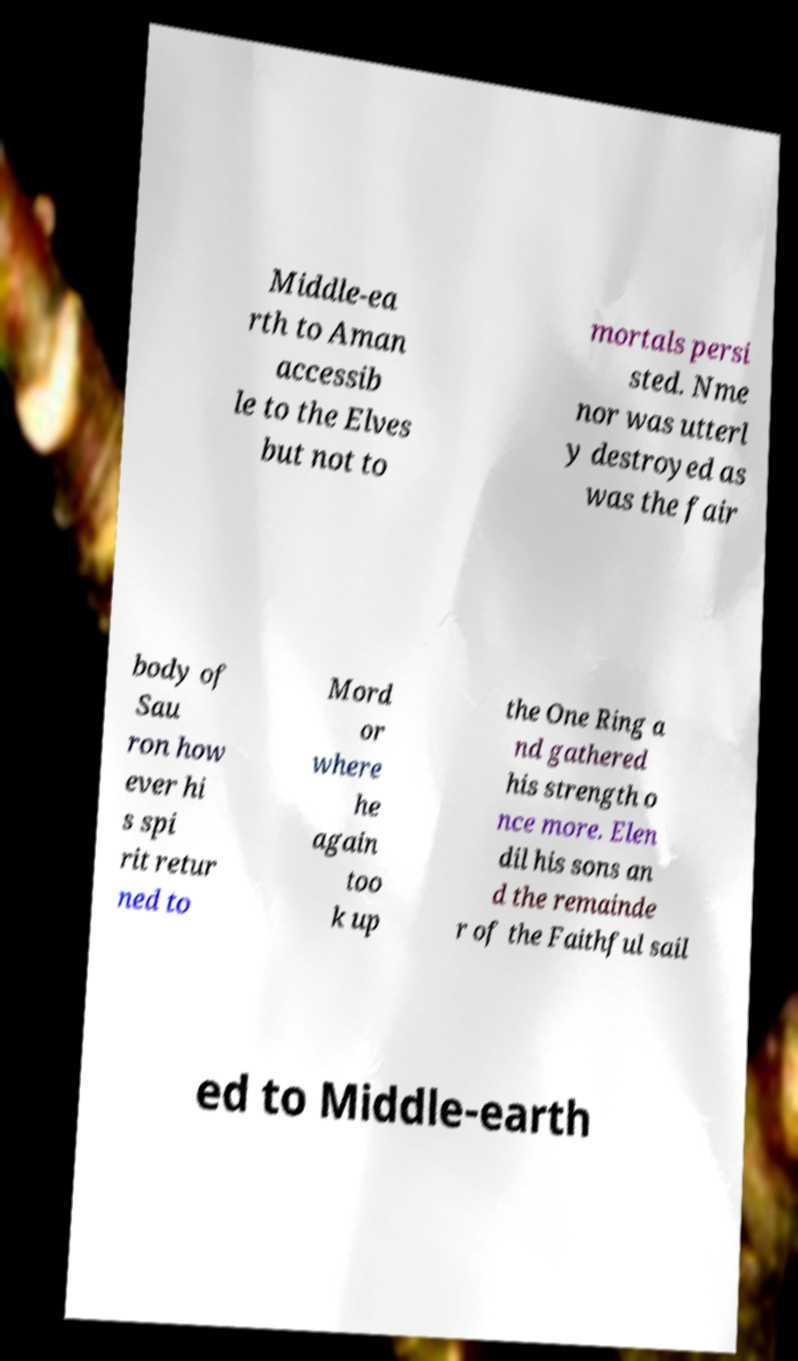Please read and relay the text visible in this image. What does it say? Middle-ea rth to Aman accessib le to the Elves but not to mortals persi sted. Nme nor was utterl y destroyed as was the fair body of Sau ron how ever hi s spi rit retur ned to Mord or where he again too k up the One Ring a nd gathered his strength o nce more. Elen dil his sons an d the remainde r of the Faithful sail ed to Middle-earth 